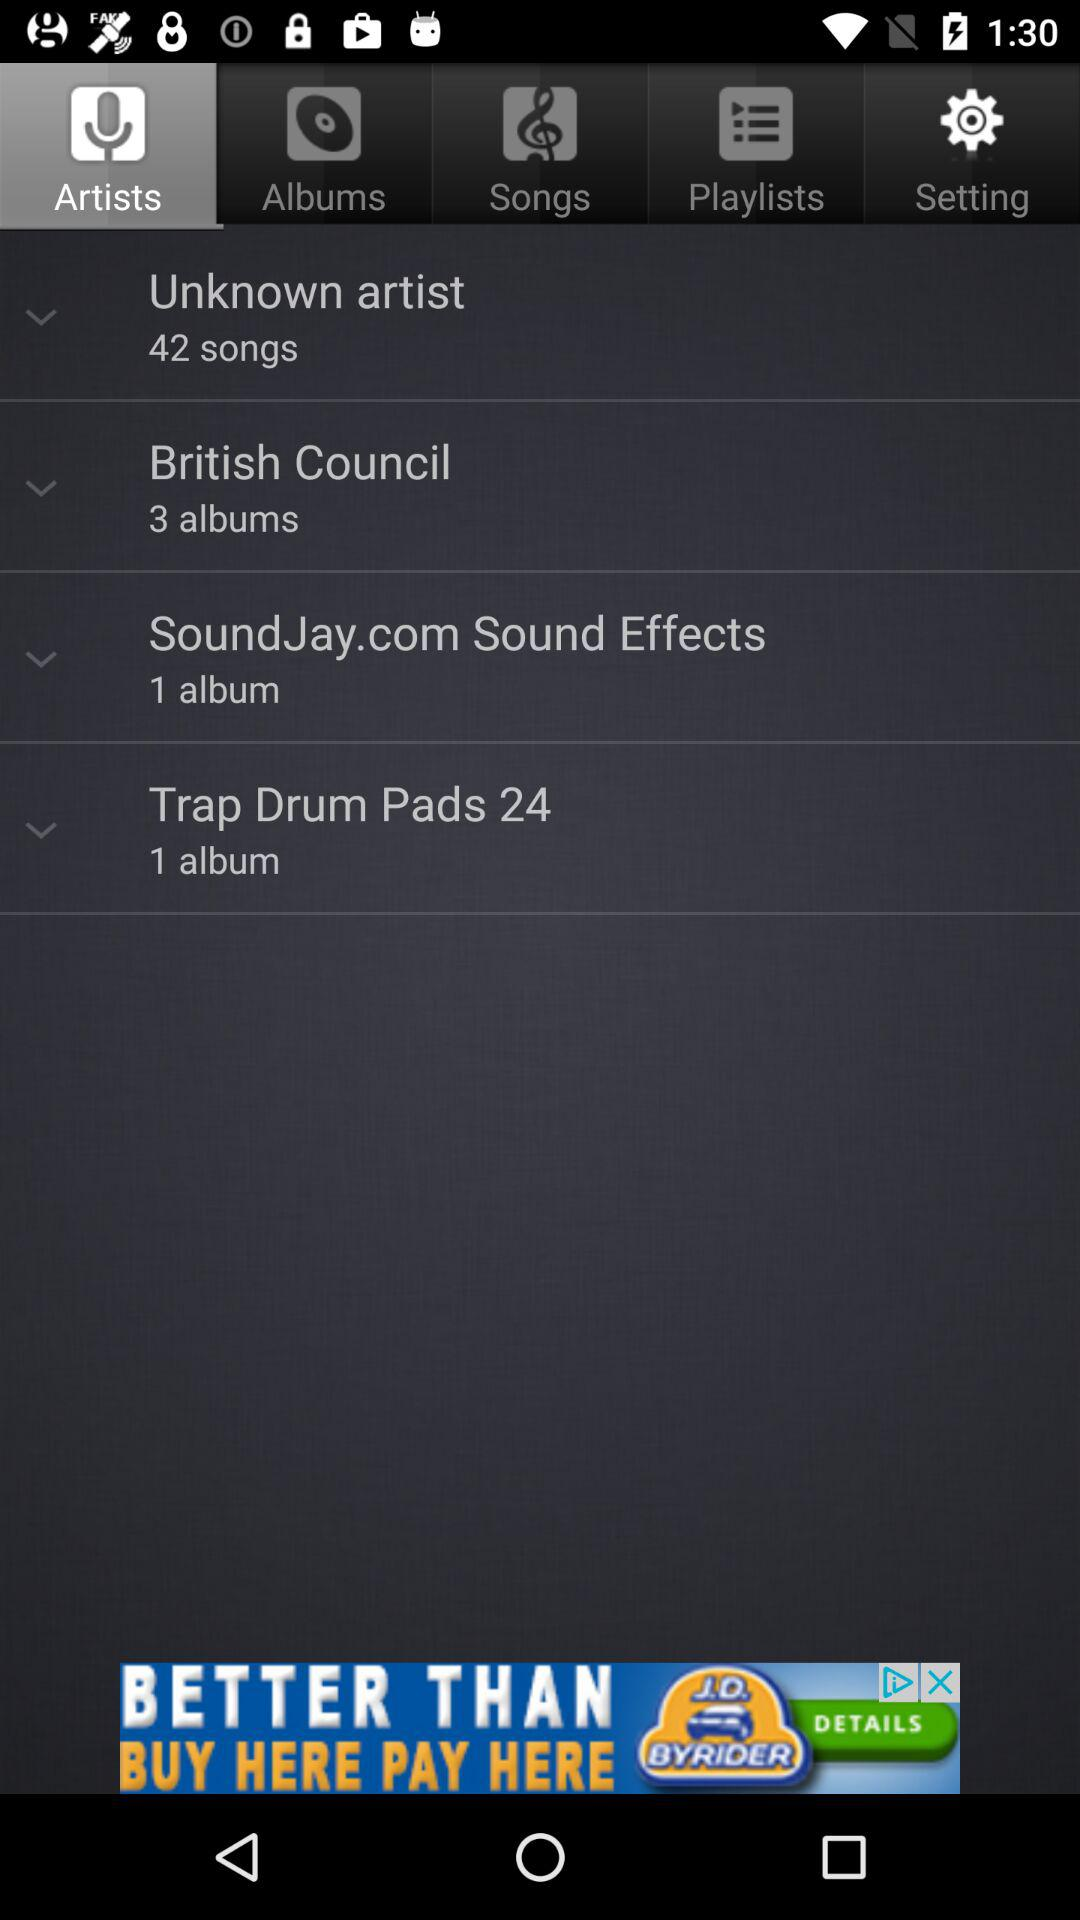Which tab is selected? The selected tab is "Artists". 